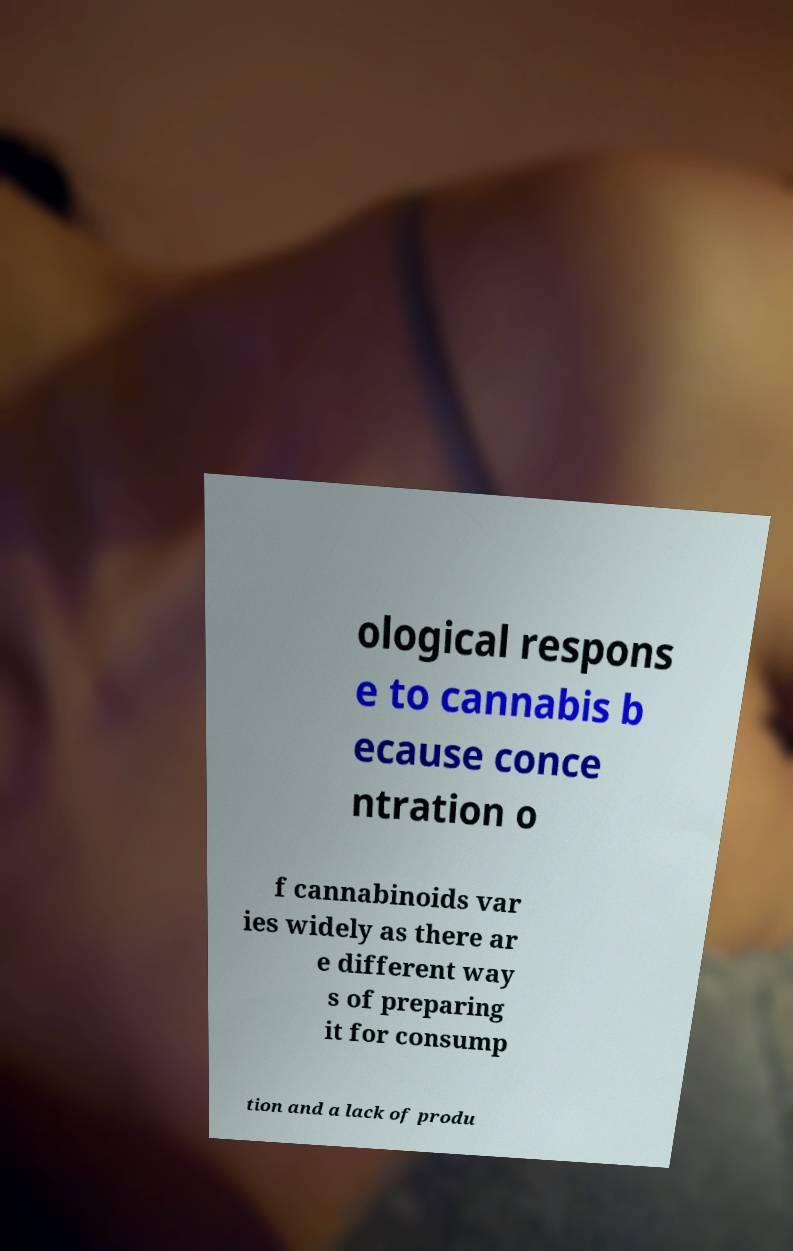Could you assist in decoding the text presented in this image and type it out clearly? ological respons e to cannabis b ecause conce ntration o f cannabinoids var ies widely as there ar e different way s of preparing it for consump tion and a lack of produ 